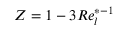<formula> <loc_0><loc_0><loc_500><loc_500>Z = 1 - 3 R e _ { l } ^ { * - 1 }</formula> 